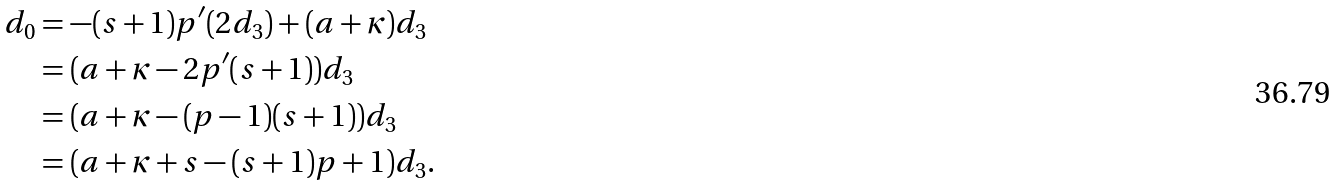<formula> <loc_0><loc_0><loc_500><loc_500>d _ { 0 } & = - ( s + 1 ) p ^ { \prime } ( 2 d _ { 3 } ) + ( a + \kappa ) d _ { 3 } \\ & = ( a + \kappa - 2 p ^ { \prime } ( s + 1 ) ) d _ { 3 } \\ & = ( a + \kappa - ( p - 1 ) ( s + 1 ) ) d _ { 3 } \\ & = ( a + \kappa + s - ( s + 1 ) p + 1 ) d _ { 3 } .</formula> 